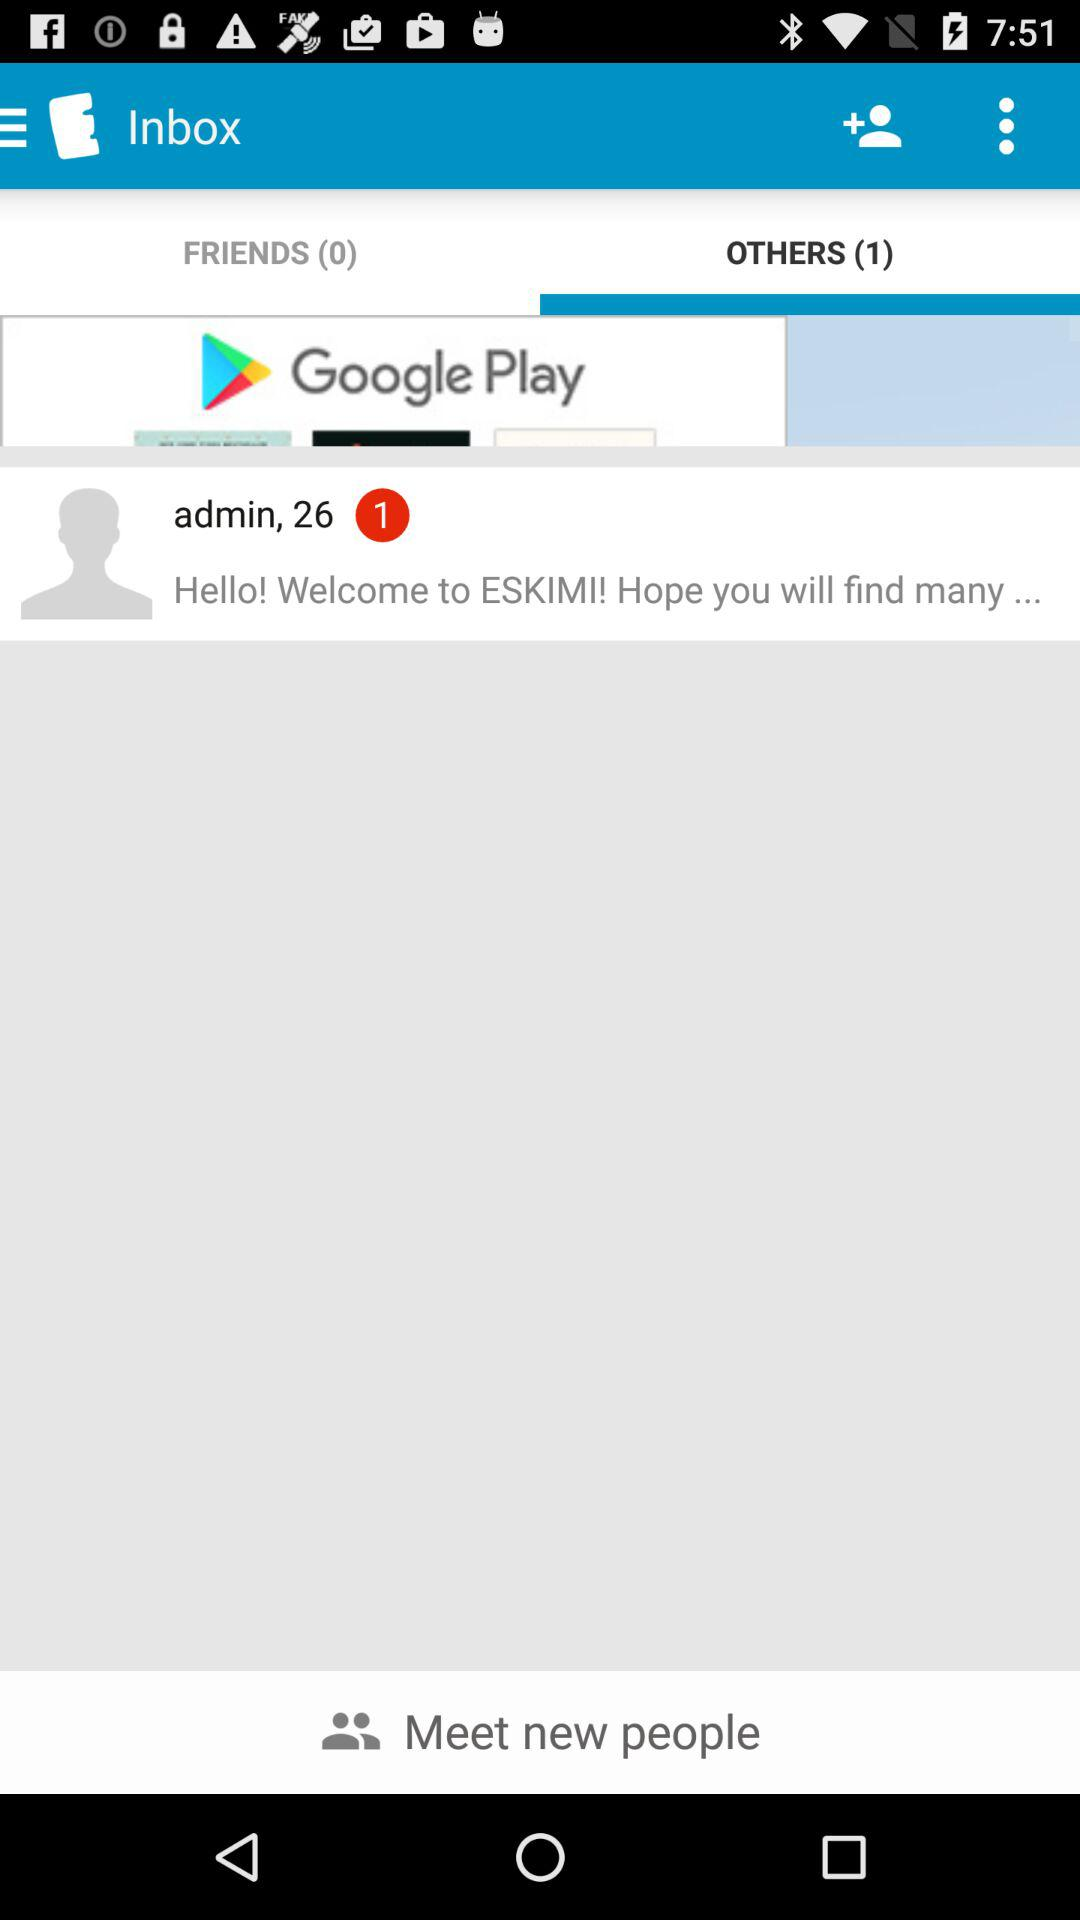Which tab is selected? The selected tab is "OTHERS (1)". 